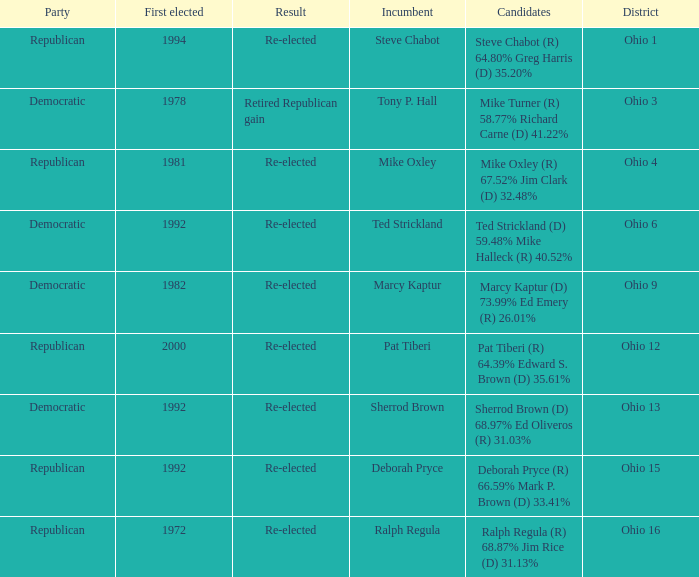In what district was the incumbent Steve Chabot?  Ohio 1. 